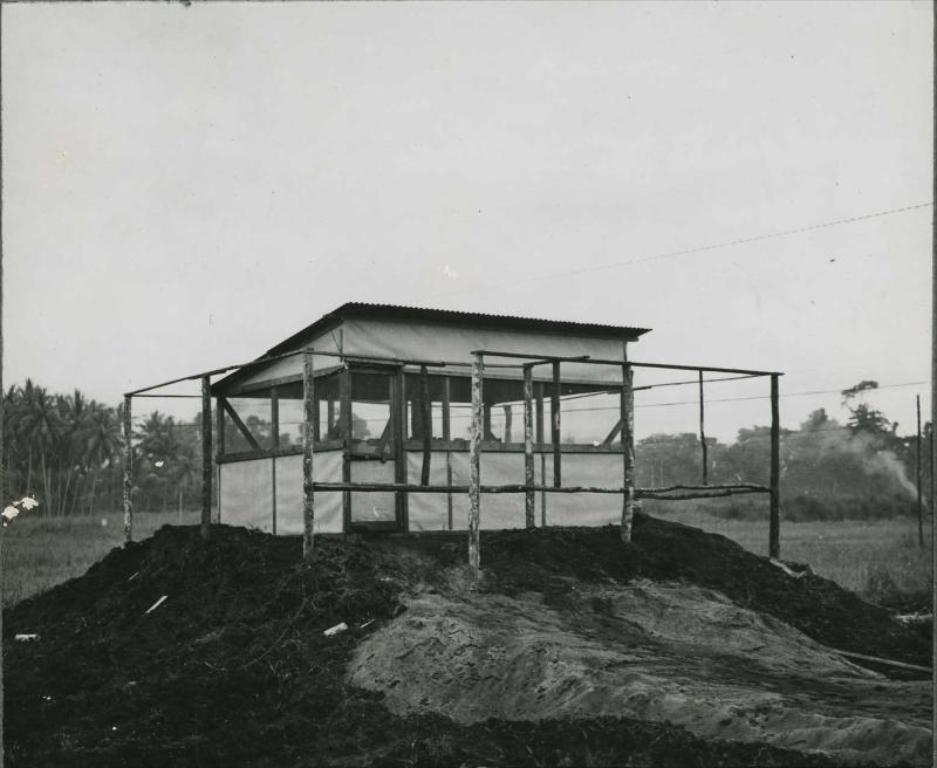Please provide a concise description of this image. In this picture we can see poles, shed, grass, smoke and trees. In the background of the image we can see the sky. 